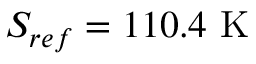Convert formula to latex. <formula><loc_0><loc_0><loc_500><loc_500>S _ { r e f } = 1 1 0 . 4 K</formula> 